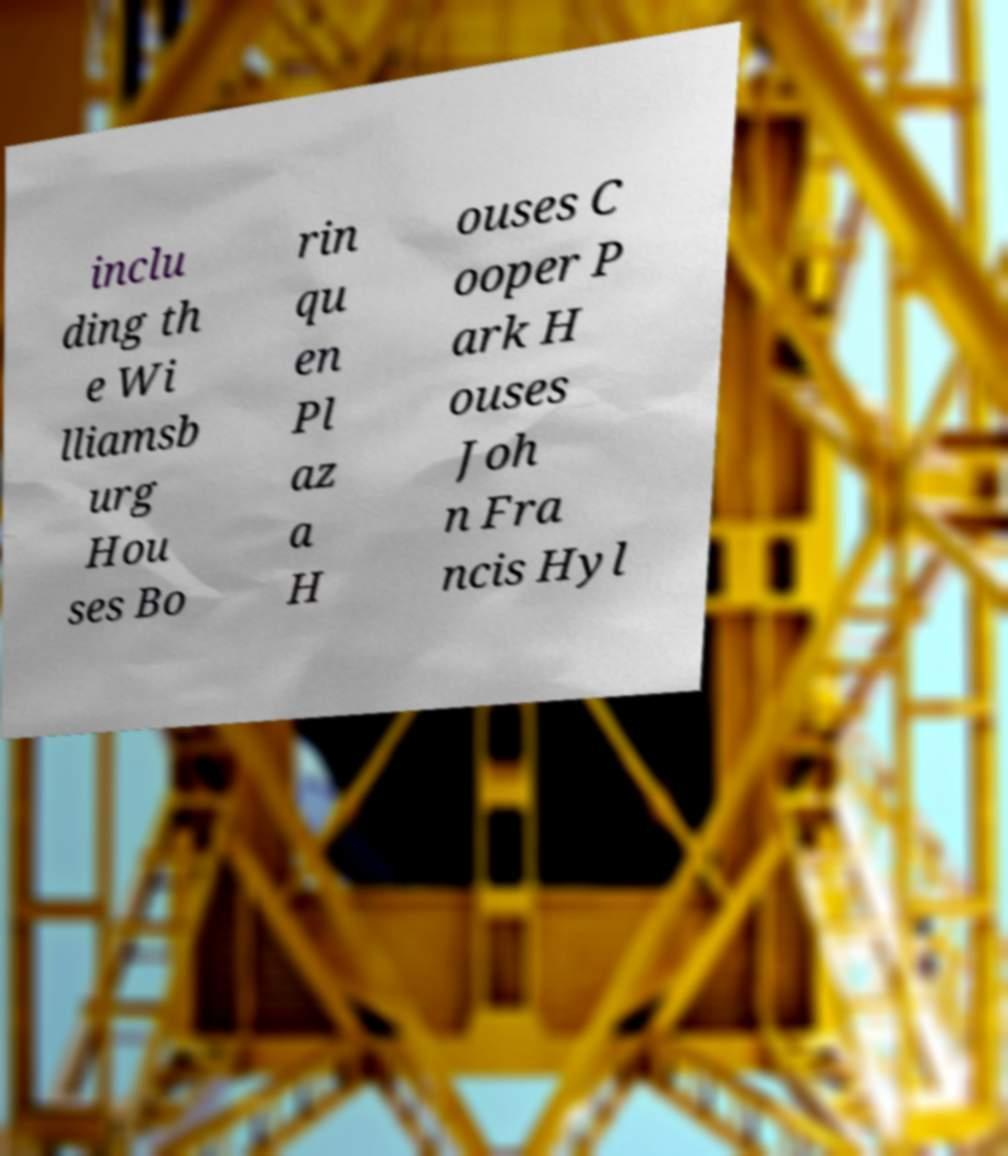Can you read and provide the text displayed in the image?This photo seems to have some interesting text. Can you extract and type it out for me? inclu ding th e Wi lliamsb urg Hou ses Bo rin qu en Pl az a H ouses C ooper P ark H ouses Joh n Fra ncis Hyl 